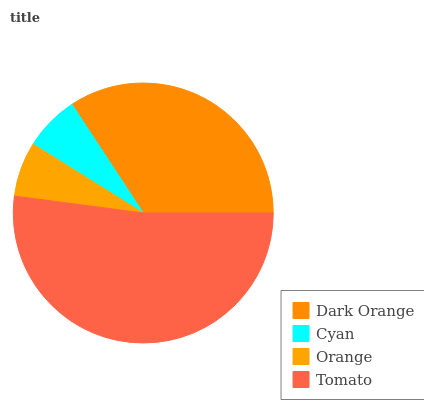Is Orange the minimum?
Answer yes or no. Yes. Is Tomato the maximum?
Answer yes or no. Yes. Is Cyan the minimum?
Answer yes or no. No. Is Cyan the maximum?
Answer yes or no. No. Is Dark Orange greater than Cyan?
Answer yes or no. Yes. Is Cyan less than Dark Orange?
Answer yes or no. Yes. Is Cyan greater than Dark Orange?
Answer yes or no. No. Is Dark Orange less than Cyan?
Answer yes or no. No. Is Dark Orange the high median?
Answer yes or no. Yes. Is Cyan the low median?
Answer yes or no. Yes. Is Cyan the high median?
Answer yes or no. No. Is Dark Orange the low median?
Answer yes or no. No. 